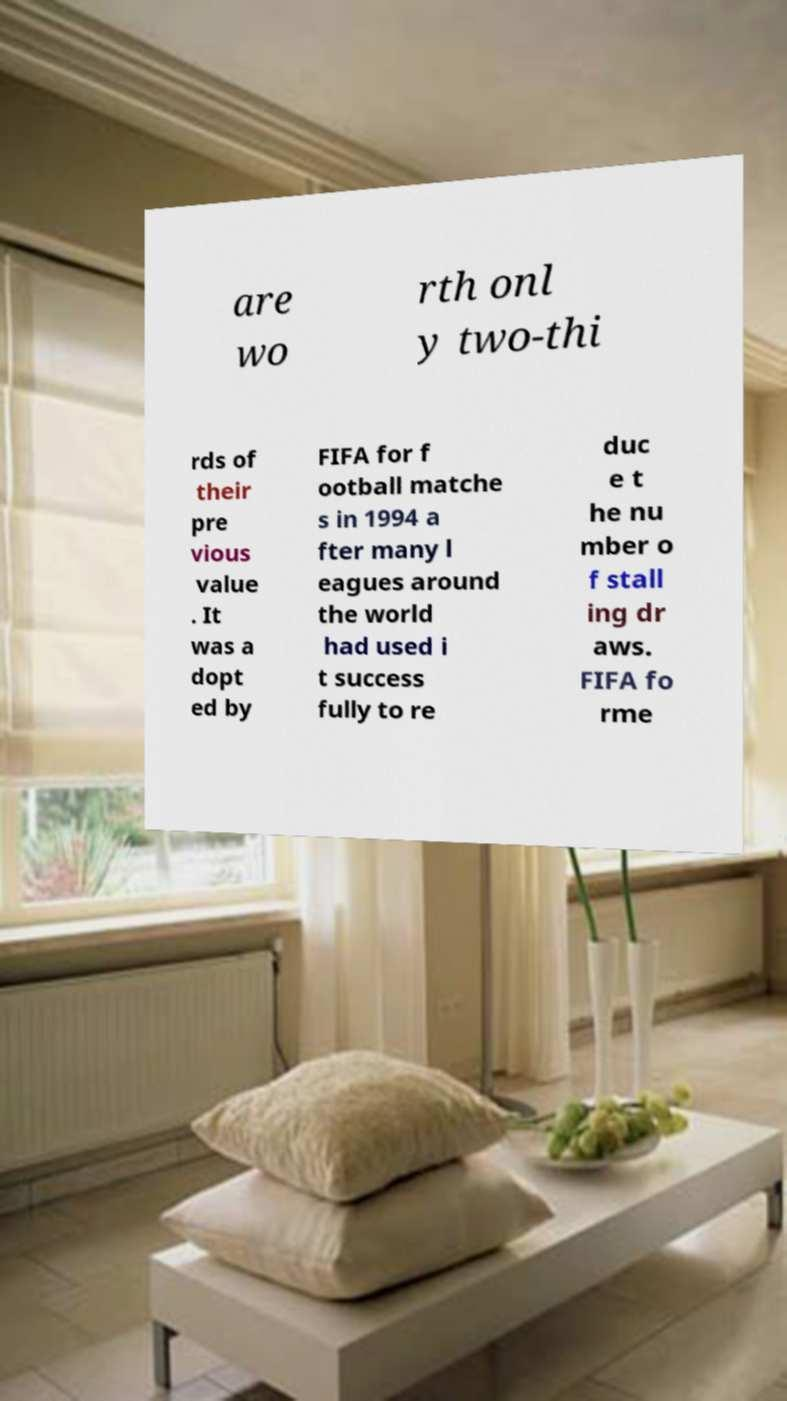I need the written content from this picture converted into text. Can you do that? are wo rth onl y two-thi rds of their pre vious value . It was a dopt ed by FIFA for f ootball matche s in 1994 a fter many l eagues around the world had used i t success fully to re duc e t he nu mber o f stall ing dr aws. FIFA fo rme 